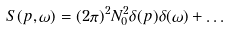Convert formula to latex. <formula><loc_0><loc_0><loc_500><loc_500>S ( p , \omega ) = ( 2 \pi ) ^ { 2 } N _ { 0 } ^ { 2 } \delta ( p ) \delta ( \omega ) + \dots</formula> 